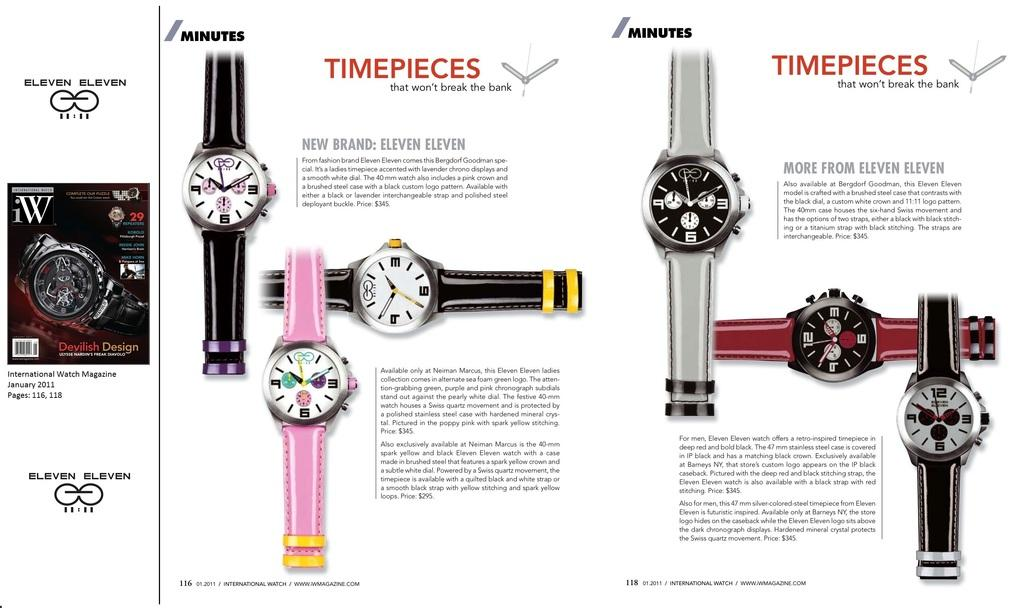<image>
Share a concise interpretation of the image provided. Magazine full with timepieces in all different colors. 